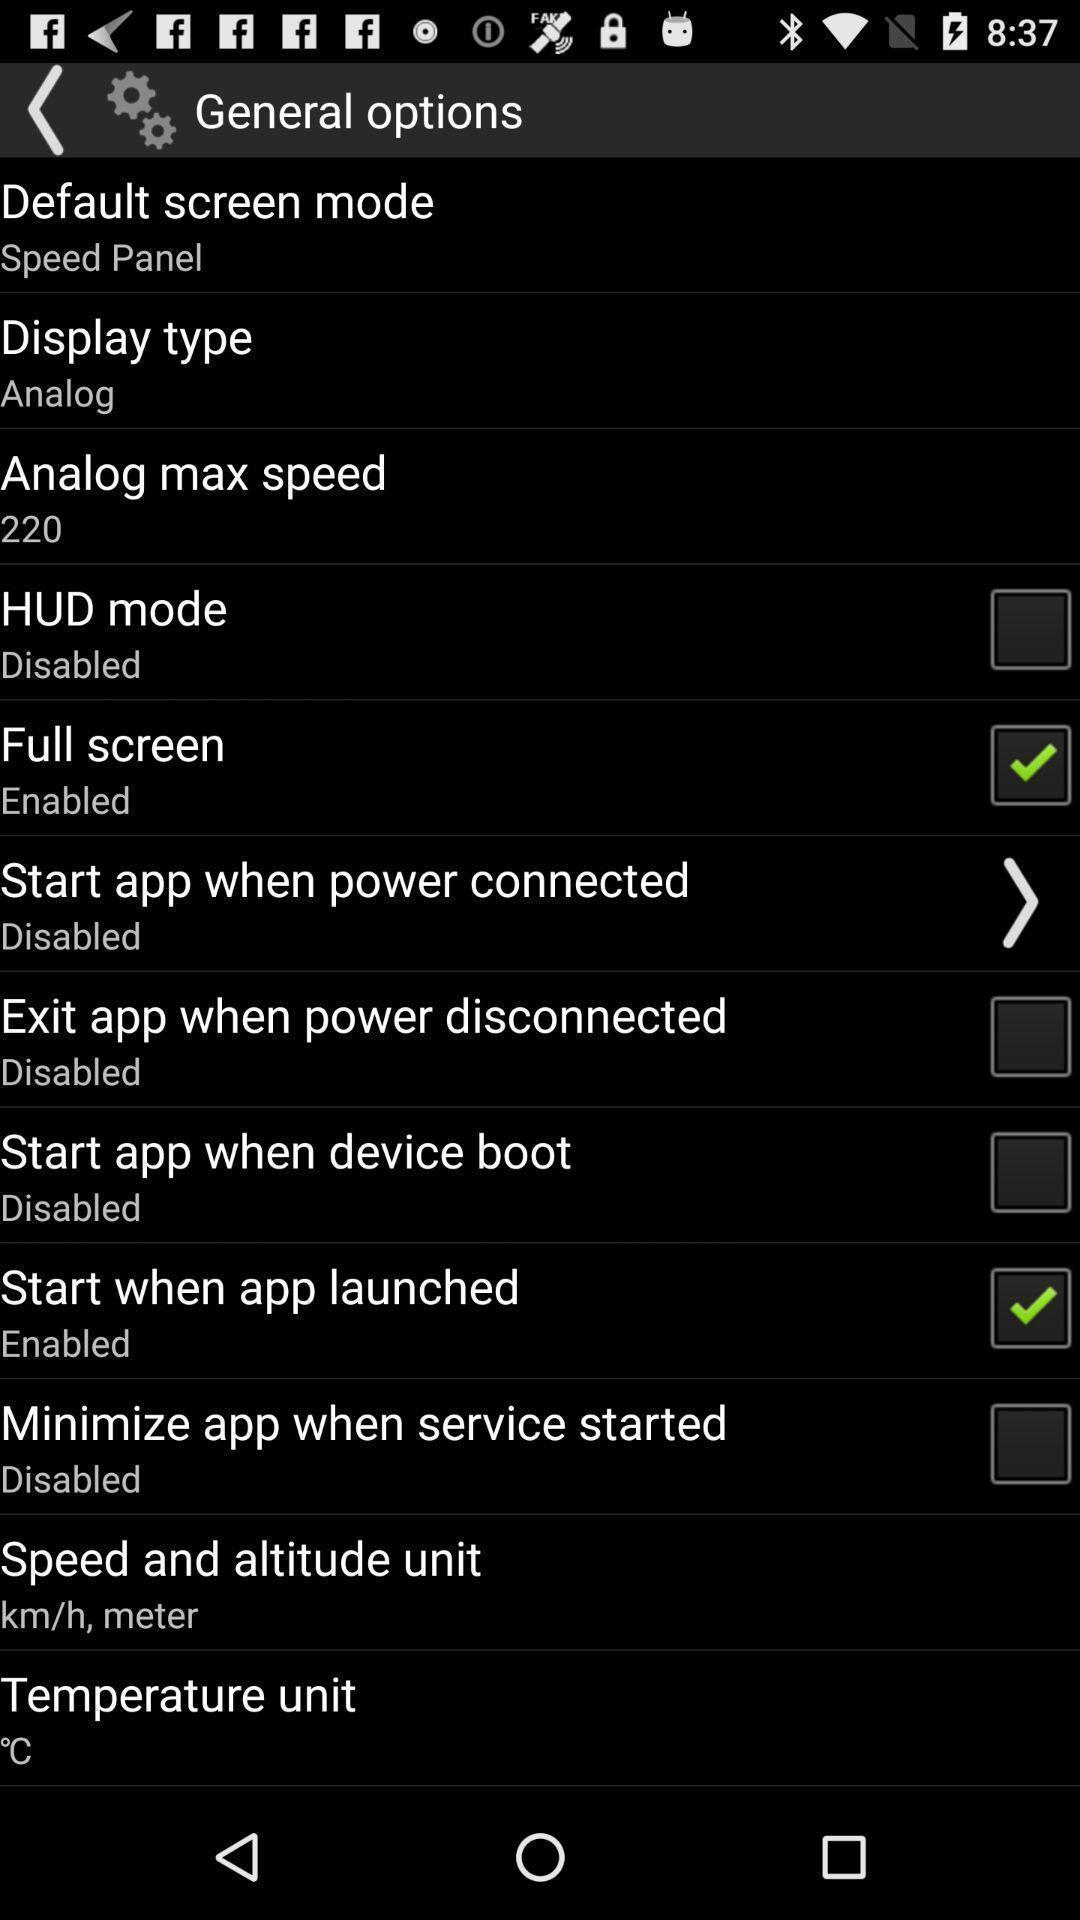Tell me about the visual elements in this screen capture. Page displaying with list of options for different settings. 